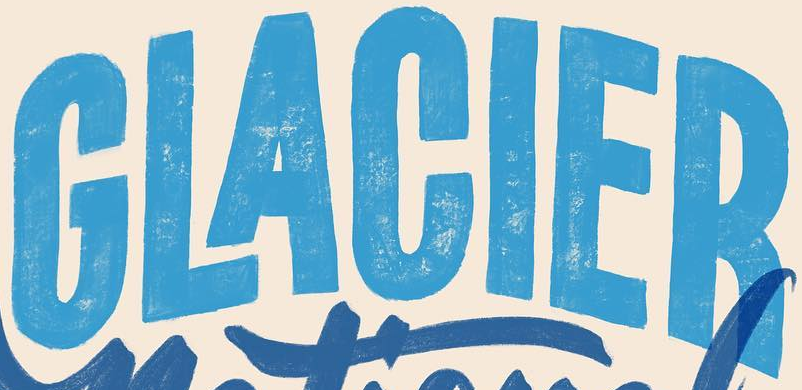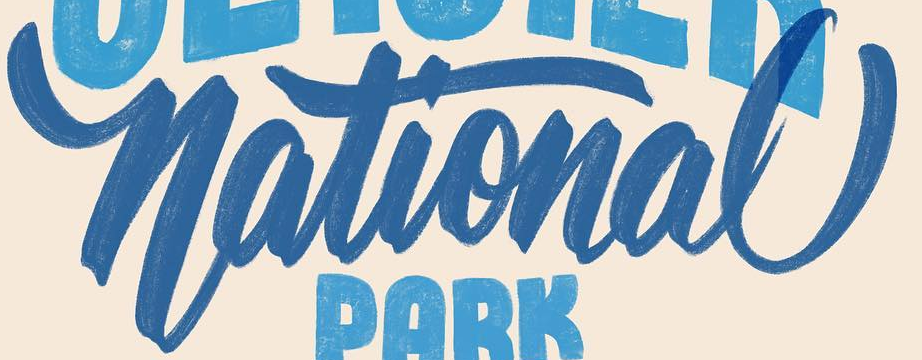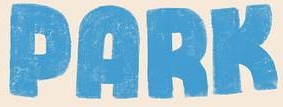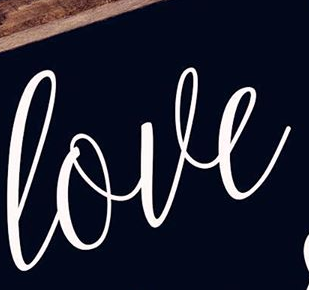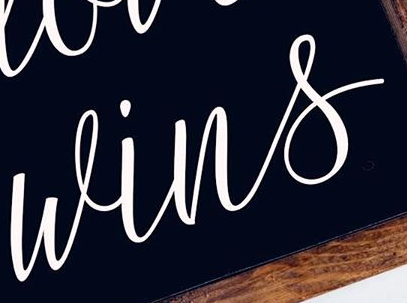What text appears in these images from left to right, separated by a semicolon? GLACIER; National; PARK; love; wins 